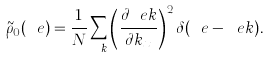Convert formula to latex. <formula><loc_0><loc_0><loc_500><loc_500>\tilde { \rho } _ { 0 } ( \ e ) = \frac { 1 } { N } \sum _ { \ k } \left ( \frac { \partial \ e k } { \partial k _ { x } } \right ) ^ { 2 } \delta ( \ e - \ e k ) .</formula> 